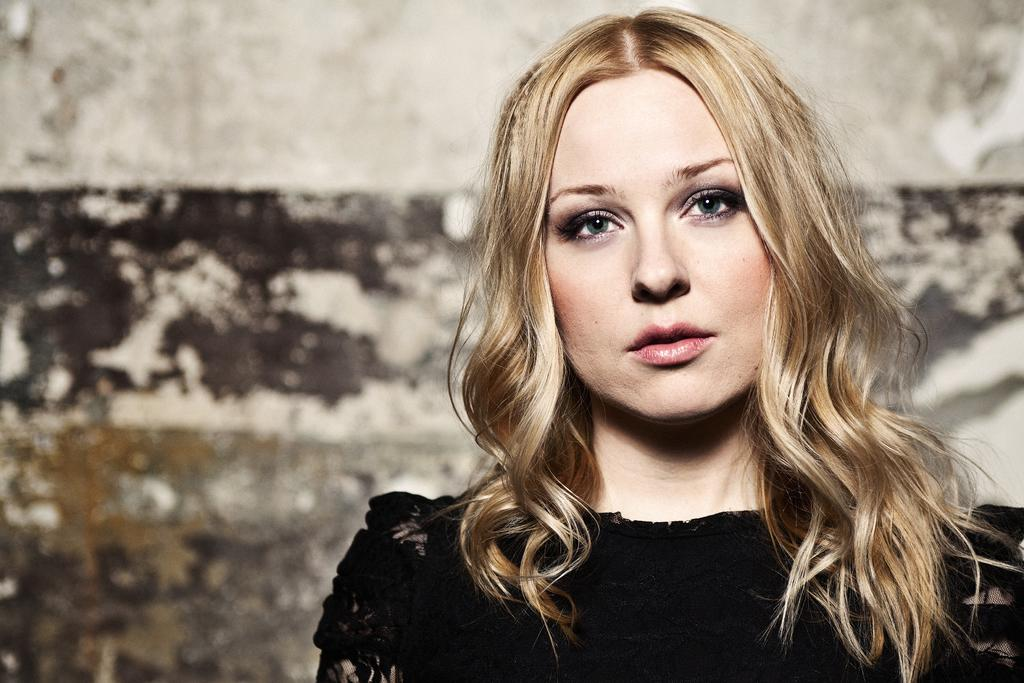What is present in the image? There is a woman in the image. Can you describe the background of the image? There is a wall visible in the background of the image, although the image quality in the background is not clear. What year is depicted in the image? There is no specific year depicted in the image; it does not contain any elements that would indicate a particular time period. How many men are present in the image? There are no men present in the image; it only features a woman. 